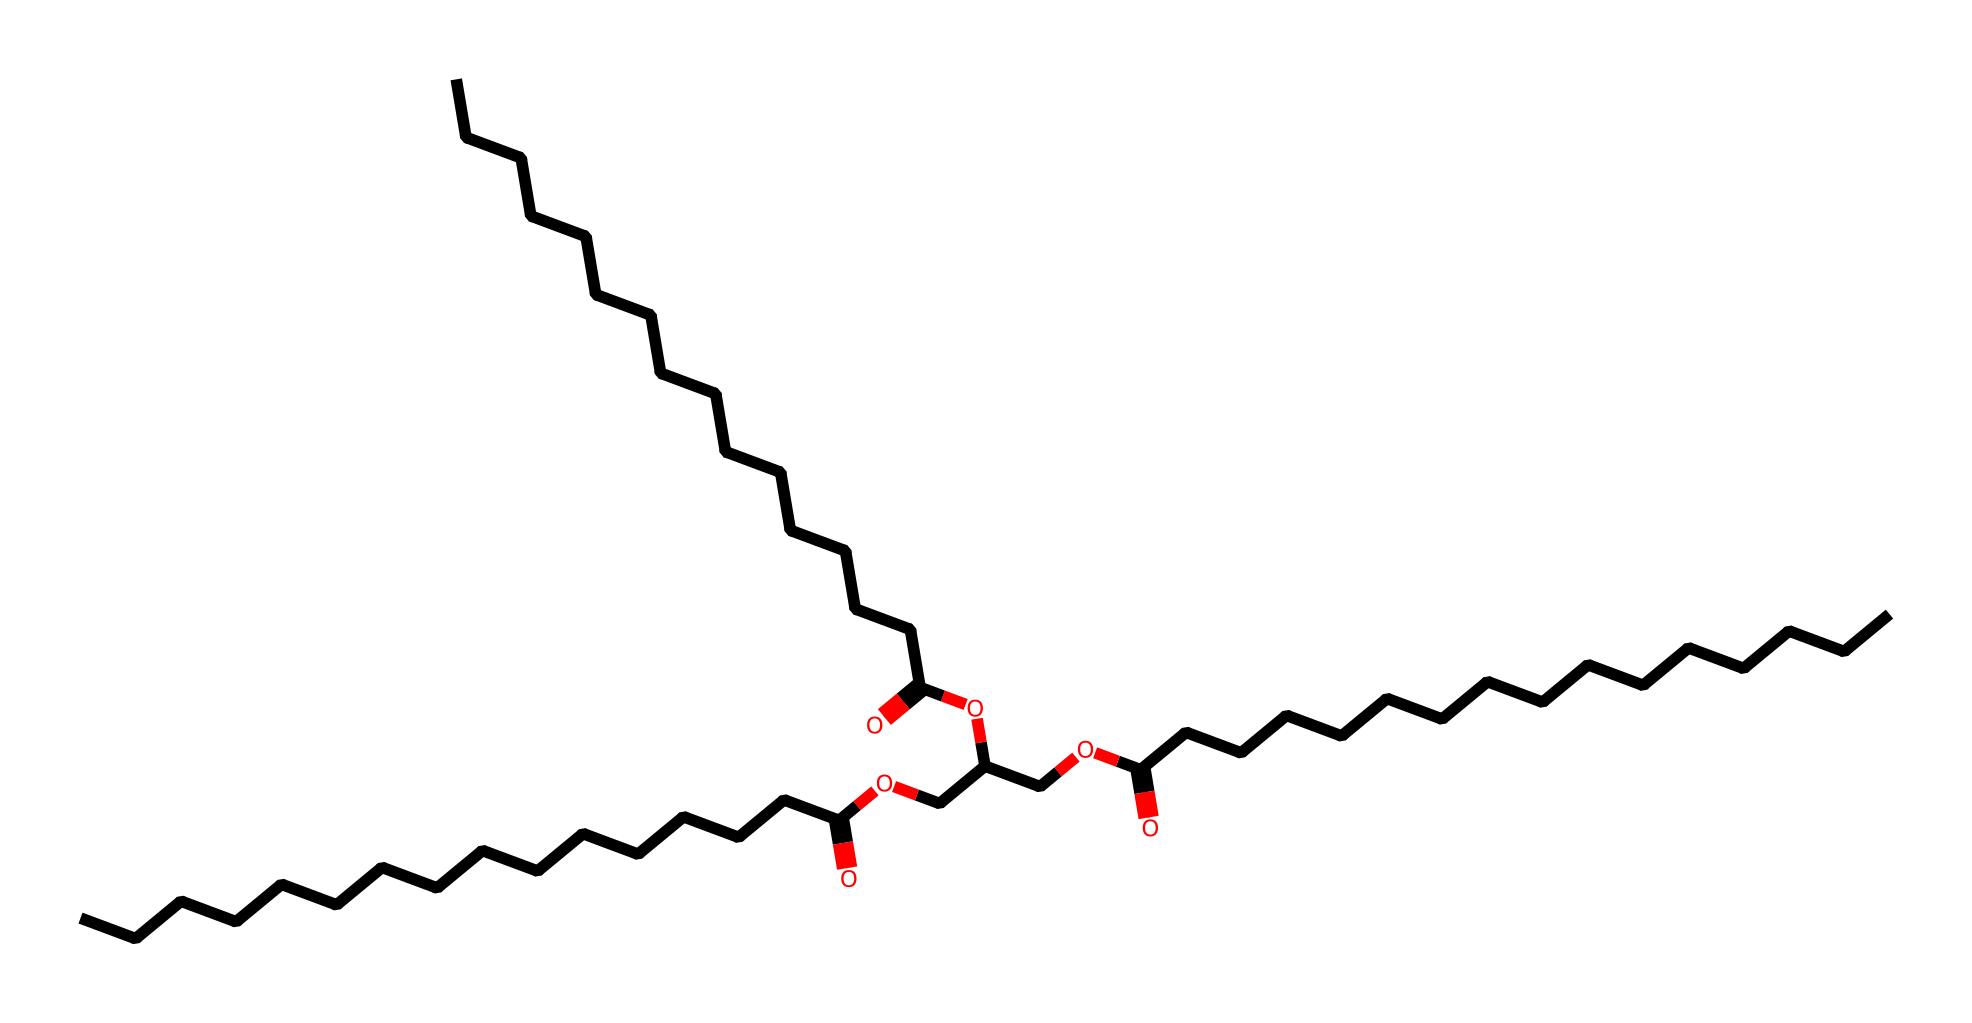What is the main functional group present in lanolin? The main functional group in this chemical is the carboxylic acid, indicated by the “=O” and “-OH” groups present in the structure.
Answer: carboxylic acid How many carbon atoms are present in lanolin? By counting the "C" elements in the SMILES representation, there are a total of 39 carbon atoms present in the structure.
Answer: 39 How many ester links are present in lanolin? The ester links are formed by the -COOC- groups in the structure. There are three ester linkages when analyzing the entire molecule.
Answer: 3 What type of compound is lanolin classified as? Based on its structure, lanolin is classified as a natural lipid due to the presence of long hydrocarbon chains and derived fatty acids.
Answer: natural lipid Which part of the lanolin structure contributes to its lubricating properties? The long hydrocarbon chains provide hydrophobic characteristics that enhance the lubricant properties of lanolin, making it effective in reducing friction.
Answer: long hydrocarbon chains 